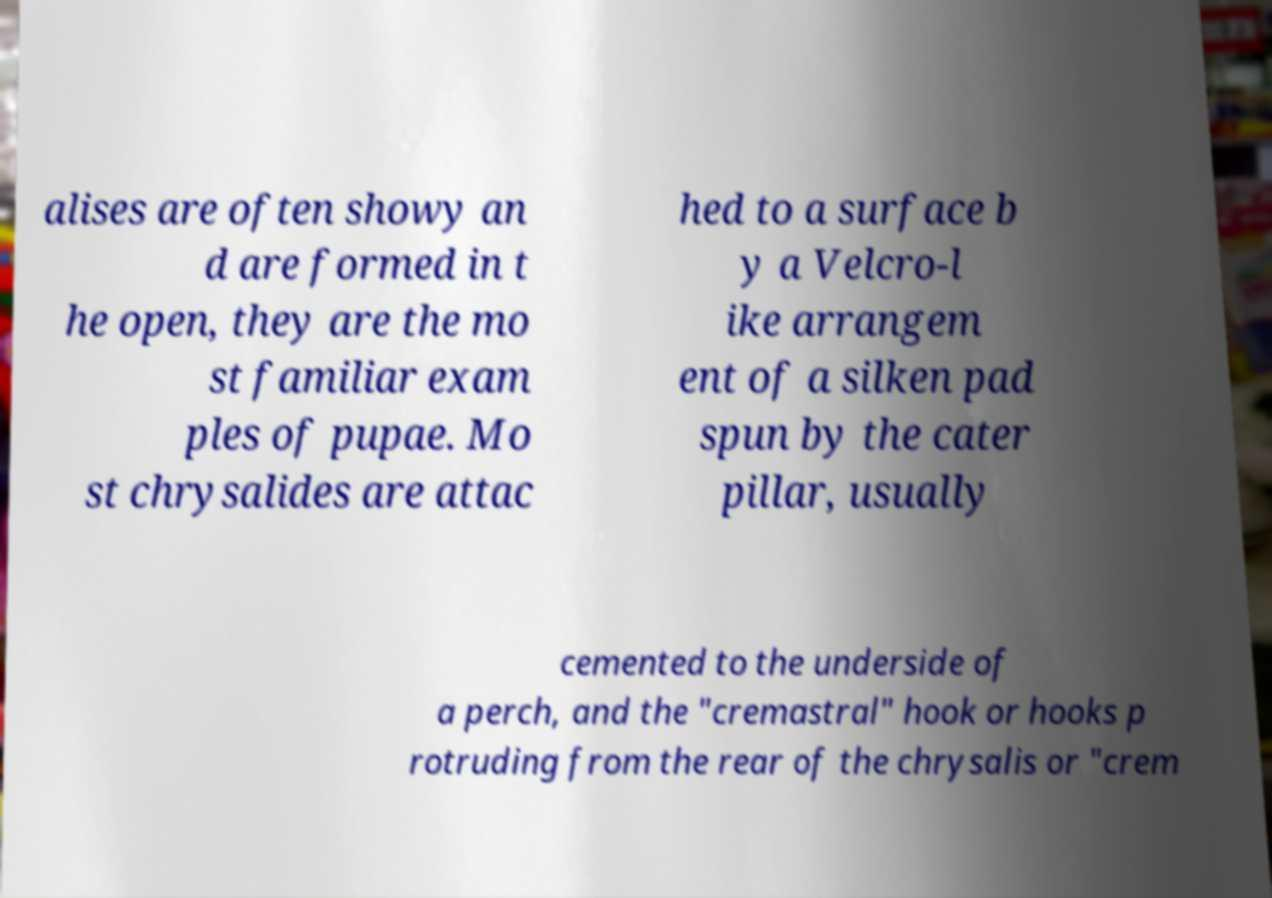There's text embedded in this image that I need extracted. Can you transcribe it verbatim? alises are often showy an d are formed in t he open, they are the mo st familiar exam ples of pupae. Mo st chrysalides are attac hed to a surface b y a Velcro-l ike arrangem ent of a silken pad spun by the cater pillar, usually cemented to the underside of a perch, and the "cremastral" hook or hooks p rotruding from the rear of the chrysalis or "crem 